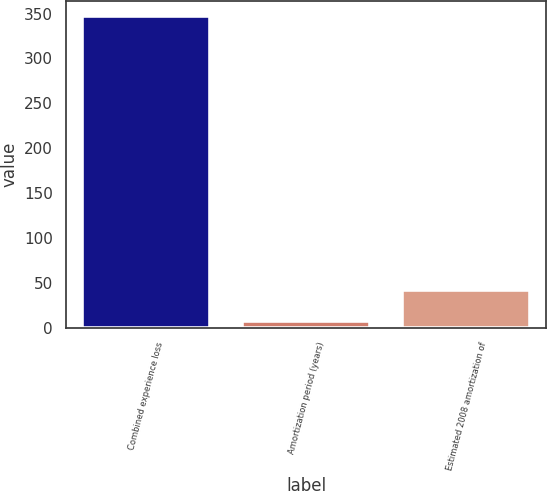<chart> <loc_0><loc_0><loc_500><loc_500><bar_chart><fcel>Combined experience loss<fcel>Amortization period (years)<fcel>Estimated 2008 amortization of<nl><fcel>347<fcel>8<fcel>41.9<nl></chart> 